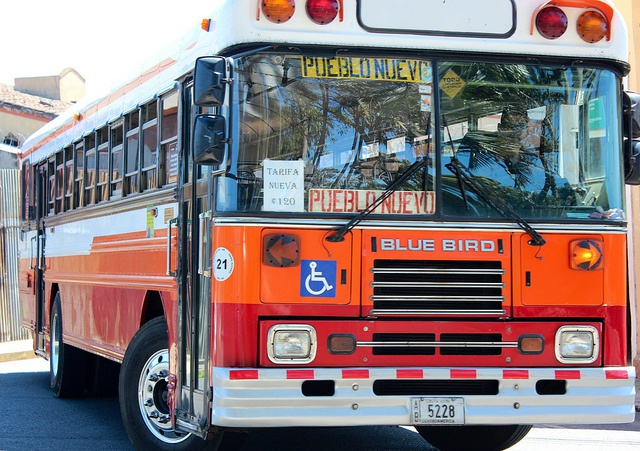Describe the objects in this image and their specific colors. I can see bus in black, white, lightgray, gray, and red tones and people in white, black, gray, and blue tones in this image. 